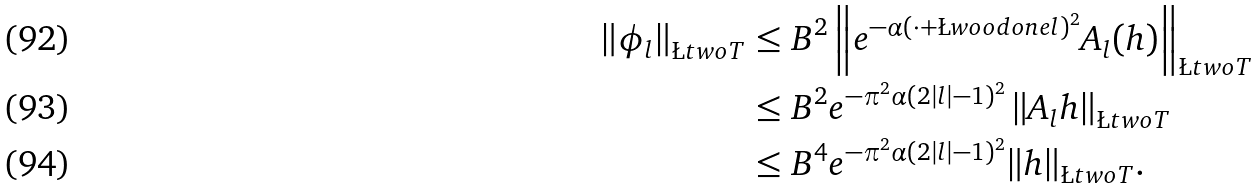<formula> <loc_0><loc_0><loc_500><loc_500>\left \| \phi _ { l } \right \| _ { \L t w o T } & \leq B ^ { 2 } \left \| e ^ { - \alpha ( \cdot + \L w o o d o n e l ) ^ { 2 } } A _ { l } ( h ) \right \| _ { \L t w o T } \\ & \leq B ^ { 2 } e ^ { - \pi ^ { 2 } \alpha ( 2 | l | - 1 ) ^ { 2 } } \left \| A _ { l } h \right \| _ { \L t w o T } \\ & \leq B ^ { 4 } e ^ { - \pi ^ { 2 } \alpha ( 2 | l | - 1 ) ^ { 2 } } \| h \| _ { \L t w o T } .</formula> 